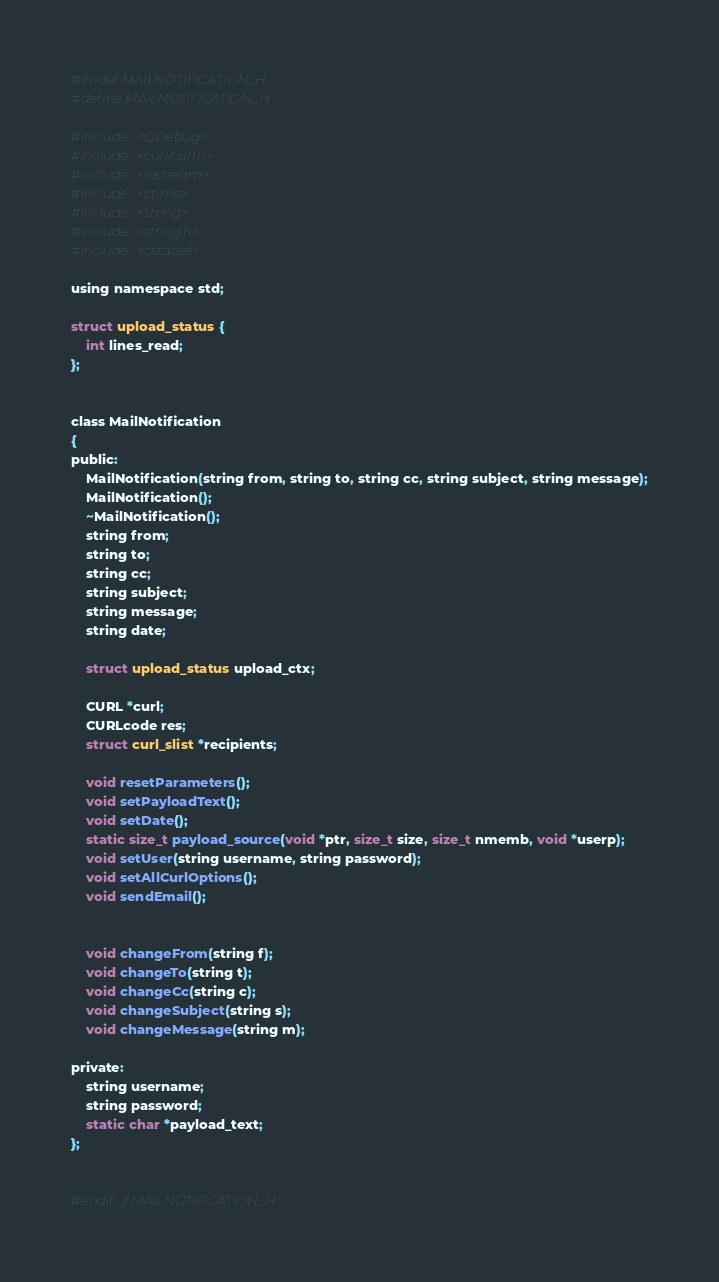Convert code to text. <code><loc_0><loc_0><loc_500><loc_500><_C_>#ifndef MAILNOTIFICATION_H
#define MAILNOTIFICATION_H

#include <QDebug>
#include <curl/curl.h>
#include <iostream>
#include <ctime>
#include <string>
#include <string.h>
#include <cstddef>

using namespace std;

struct upload_status {
    int lines_read;
};


class MailNotification
{
public:
    MailNotification(string from, string to, string cc, string subject, string message);
    MailNotification();
    ~MailNotification();
    string from;
    string to;
    string cc;
    string subject;
    string message;
    string date;

    struct upload_status upload_ctx;

    CURL *curl;
    CURLcode res;
    struct curl_slist *recipients;

    void resetParameters();
    void setPayloadText();
    void setDate();
    static size_t payload_source(void *ptr, size_t size, size_t nmemb, void *userp);
    void setUser(string username, string password);
    void setAllCurlOptions();
    void sendEmail();


    void changeFrom(string f);
    void changeTo(string t);
    void changeCc(string c);
    void changeSubject(string s);
    void changeMessage(string m);

private:
    string username;
    string password;
    static char *payload_text;
};


#endif // MAILNOTIFICATION_H
</code> 